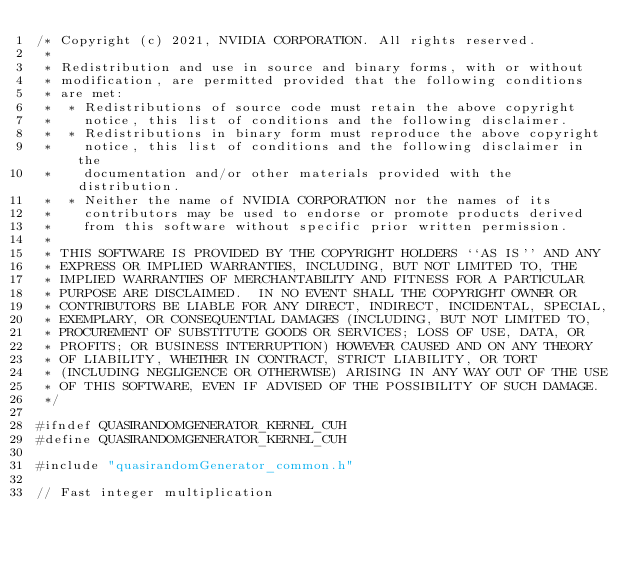<code> <loc_0><loc_0><loc_500><loc_500><_Cuda_>/* Copyright (c) 2021, NVIDIA CORPORATION. All rights reserved.
 *
 * Redistribution and use in source and binary forms, with or without
 * modification, are permitted provided that the following conditions
 * are met:
 *  * Redistributions of source code must retain the above copyright
 *    notice, this list of conditions and the following disclaimer.
 *  * Redistributions in binary form must reproduce the above copyright
 *    notice, this list of conditions and the following disclaimer in the
 *    documentation and/or other materials provided with the distribution.
 *  * Neither the name of NVIDIA CORPORATION nor the names of its
 *    contributors may be used to endorse or promote products derived
 *    from this software without specific prior written permission.
 *
 * THIS SOFTWARE IS PROVIDED BY THE COPYRIGHT HOLDERS ``AS IS'' AND ANY
 * EXPRESS OR IMPLIED WARRANTIES, INCLUDING, BUT NOT LIMITED TO, THE
 * IMPLIED WARRANTIES OF MERCHANTABILITY AND FITNESS FOR A PARTICULAR
 * PURPOSE ARE DISCLAIMED.  IN NO EVENT SHALL THE COPYRIGHT OWNER OR
 * CONTRIBUTORS BE LIABLE FOR ANY DIRECT, INDIRECT, INCIDENTAL, SPECIAL,
 * EXEMPLARY, OR CONSEQUENTIAL DAMAGES (INCLUDING, BUT NOT LIMITED TO,
 * PROCUREMENT OF SUBSTITUTE GOODS OR SERVICES; LOSS OF USE, DATA, OR
 * PROFITS; OR BUSINESS INTERRUPTION) HOWEVER CAUSED AND ON ANY THEORY
 * OF LIABILITY, WHETHER IN CONTRACT, STRICT LIABILITY, OR TORT
 * (INCLUDING NEGLIGENCE OR OTHERWISE) ARISING IN ANY WAY OUT OF THE USE
 * OF THIS SOFTWARE, EVEN IF ADVISED OF THE POSSIBILITY OF SUCH DAMAGE.
 */

#ifndef QUASIRANDOMGENERATOR_KERNEL_CUH
#define QUASIRANDOMGENERATOR_KERNEL_CUH

#include "quasirandomGenerator_common.h"

// Fast integer multiplication</code> 